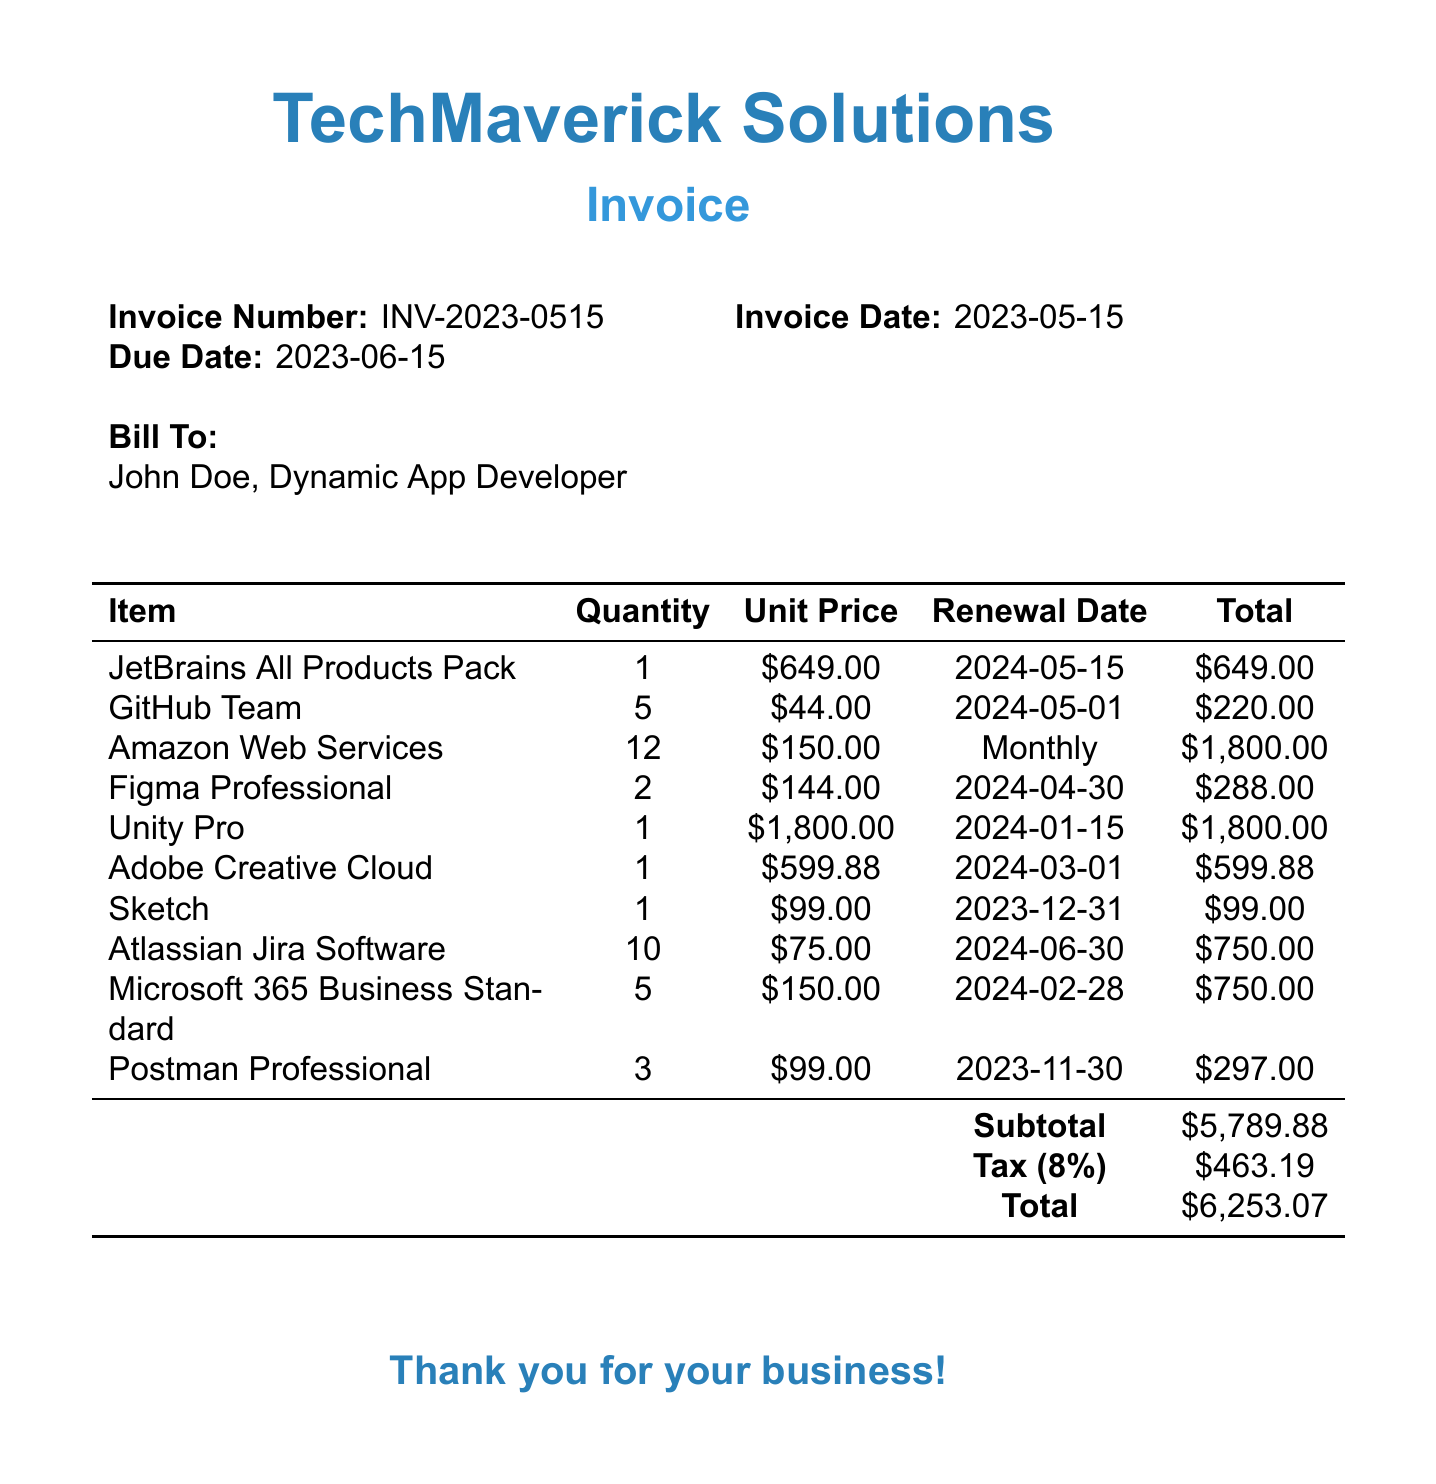What is the company name? The company name is listed at the top of the invoice document.
Answer: TechMaverick Solutions What is the invoice number? The invoice number is specified near the invoice date.
Answer: INV-2023-0515 What is the due date? The due date is indicated alongside the invoice date and number.
Answer: 2023-06-15 How many items are billed? The number of items can be counted from the list of billed items in the document.
Answer: 10 What is the renewal date for the Adobe Creative Cloud? The renewal date for the Adobe Creative Cloud is found in the itemized list.
Answer: 2024-03-01 What is the quantity of Unity Pro licenses? The quantity of Unity Pro licenses is stated in the itemized section of the document.
Answer: 1 What is the subtotal amount? The subtotal amount appears in the summary table of the invoice.
Answer: 5789.88 How much tax is applied? The tax amount is indicated in the summary section as a percentage of the subtotal.
Answer: 463.19 When does the Sketch license expire? The expiration date for the Sketch license is part of the item's details.
Answer: 2023-12-31 What is the total amount due? The total amount is the final figure at the bottom of the invoice summary.
Answer: 6253.07 